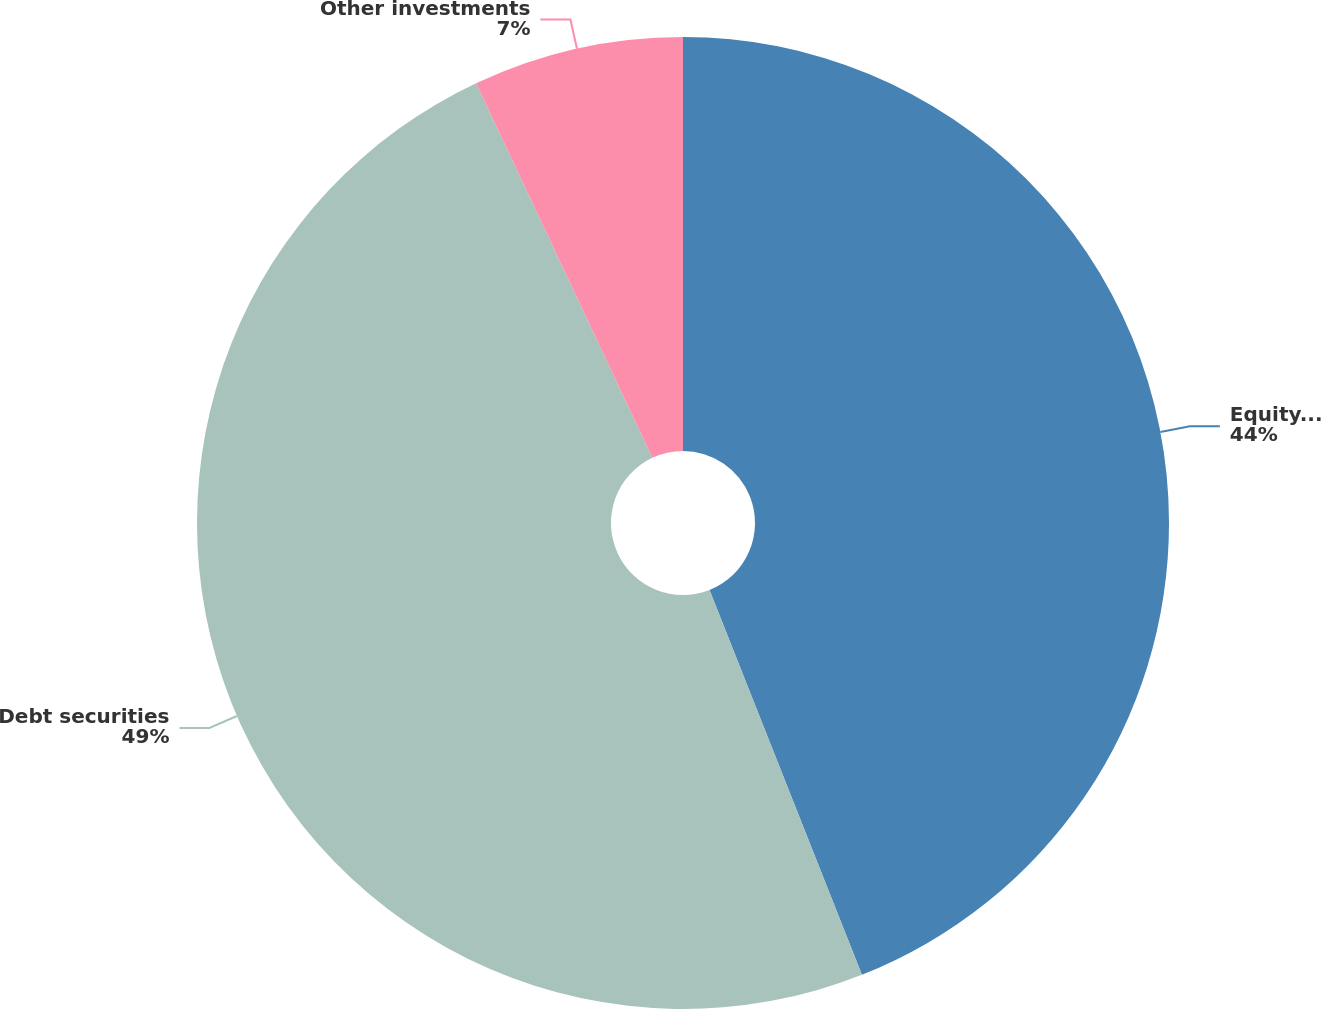Convert chart. <chart><loc_0><loc_0><loc_500><loc_500><pie_chart><fcel>Equity securities<fcel>Debt securities<fcel>Other investments<nl><fcel>44.0%<fcel>49.0%<fcel>7.0%<nl></chart> 